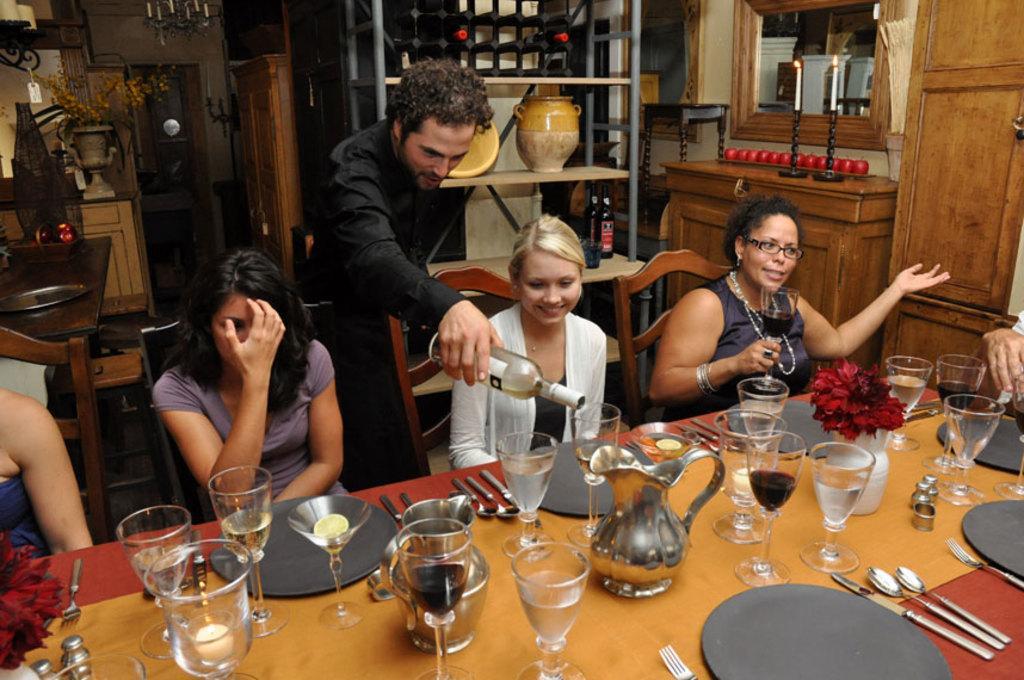Describe this image in one or two sentences. In this image there are group of persons sitting on the chairs in front of them there are glasses jugs spoons forks and plates and at the middle of the image there is a person serving the drink 